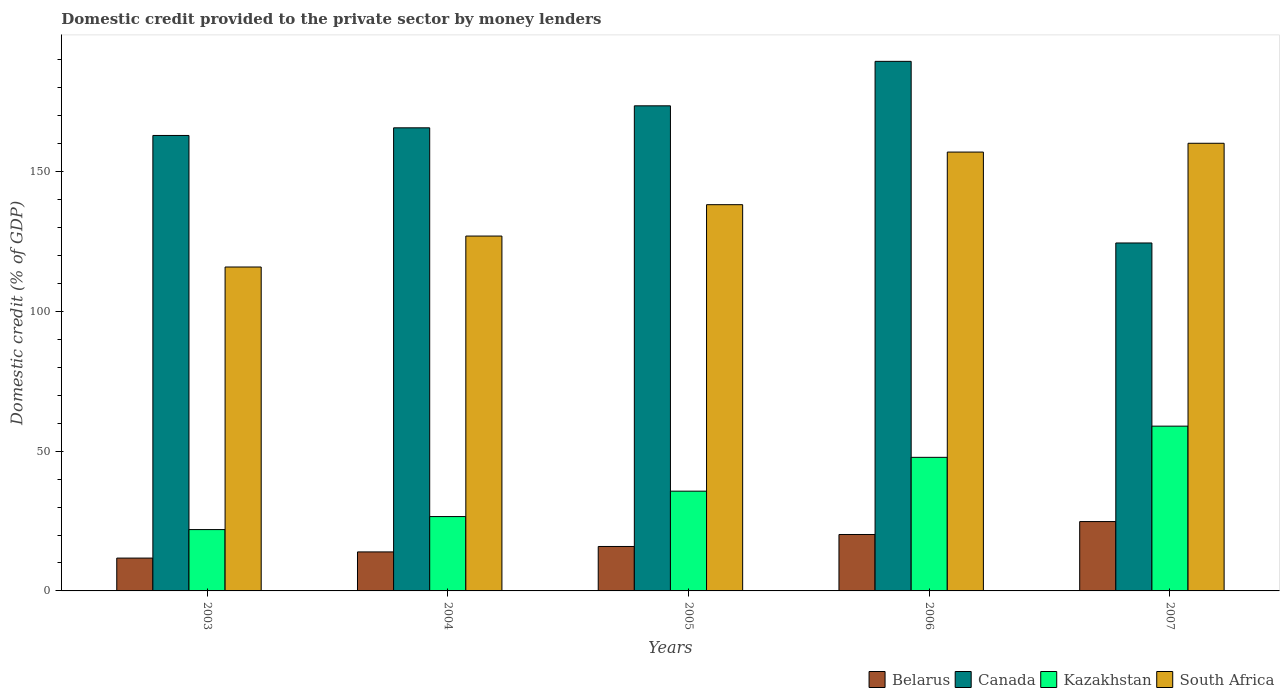Are the number of bars per tick equal to the number of legend labels?
Offer a very short reply. Yes. Are the number of bars on each tick of the X-axis equal?
Ensure brevity in your answer.  Yes. What is the domestic credit provided to the private sector by money lenders in South Africa in 2006?
Your answer should be very brief. 156.98. Across all years, what is the maximum domestic credit provided to the private sector by money lenders in Kazakhstan?
Offer a terse response. 58.94. Across all years, what is the minimum domestic credit provided to the private sector by money lenders in Kazakhstan?
Offer a very short reply. 21.94. What is the total domestic credit provided to the private sector by money lenders in Belarus in the graph?
Make the answer very short. 86.59. What is the difference between the domestic credit provided to the private sector by money lenders in Kazakhstan in 2006 and that in 2007?
Your answer should be compact. -11.16. What is the difference between the domestic credit provided to the private sector by money lenders in Belarus in 2003 and the domestic credit provided to the private sector by money lenders in South Africa in 2004?
Provide a short and direct response. -115.19. What is the average domestic credit provided to the private sector by money lenders in South Africa per year?
Make the answer very short. 139.61. In the year 2003, what is the difference between the domestic credit provided to the private sector by money lenders in South Africa and domestic credit provided to the private sector by money lenders in Canada?
Offer a terse response. -47.05. In how many years, is the domestic credit provided to the private sector by money lenders in Kazakhstan greater than 100 %?
Your answer should be compact. 0. What is the ratio of the domestic credit provided to the private sector by money lenders in Belarus in 2005 to that in 2006?
Make the answer very short. 0.79. Is the difference between the domestic credit provided to the private sector by money lenders in South Africa in 2004 and 2006 greater than the difference between the domestic credit provided to the private sector by money lenders in Canada in 2004 and 2006?
Ensure brevity in your answer.  No. What is the difference between the highest and the second highest domestic credit provided to the private sector by money lenders in Canada?
Your answer should be very brief. 15.91. What is the difference between the highest and the lowest domestic credit provided to the private sector by money lenders in Belarus?
Your answer should be compact. 13.06. In how many years, is the domestic credit provided to the private sector by money lenders in Kazakhstan greater than the average domestic credit provided to the private sector by money lenders in Kazakhstan taken over all years?
Provide a short and direct response. 2. Is the sum of the domestic credit provided to the private sector by money lenders in Belarus in 2004 and 2006 greater than the maximum domestic credit provided to the private sector by money lenders in Canada across all years?
Give a very brief answer. No. What does the 1st bar from the left in 2006 represents?
Offer a terse response. Belarus. What does the 4th bar from the right in 2003 represents?
Offer a very short reply. Belarus. How many bars are there?
Offer a terse response. 20. Are the values on the major ticks of Y-axis written in scientific E-notation?
Offer a terse response. No. Where does the legend appear in the graph?
Your answer should be very brief. Bottom right. How many legend labels are there?
Offer a very short reply. 4. What is the title of the graph?
Provide a short and direct response. Domestic credit provided to the private sector by money lenders. Does "Northern Mariana Islands" appear as one of the legend labels in the graph?
Your response must be concise. No. What is the label or title of the X-axis?
Provide a short and direct response. Years. What is the label or title of the Y-axis?
Your answer should be compact. Domestic credit (% of GDP). What is the Domestic credit (% of GDP) in Belarus in 2003?
Keep it short and to the point. 11.75. What is the Domestic credit (% of GDP) of Canada in 2003?
Offer a terse response. 162.91. What is the Domestic credit (% of GDP) of Kazakhstan in 2003?
Offer a terse response. 21.94. What is the Domestic credit (% of GDP) of South Africa in 2003?
Offer a terse response. 115.86. What is the Domestic credit (% of GDP) in Belarus in 2004?
Your response must be concise. 13.95. What is the Domestic credit (% of GDP) in Canada in 2004?
Offer a terse response. 165.65. What is the Domestic credit (% of GDP) of Kazakhstan in 2004?
Your answer should be compact. 26.59. What is the Domestic credit (% of GDP) in South Africa in 2004?
Offer a terse response. 126.93. What is the Domestic credit (% of GDP) of Belarus in 2005?
Make the answer very short. 15.9. What is the Domestic credit (% of GDP) in Canada in 2005?
Offer a very short reply. 173.52. What is the Domestic credit (% of GDP) in Kazakhstan in 2005?
Your response must be concise. 35.69. What is the Domestic credit (% of GDP) of South Africa in 2005?
Your answer should be very brief. 138.16. What is the Domestic credit (% of GDP) of Belarus in 2006?
Offer a terse response. 20.19. What is the Domestic credit (% of GDP) of Canada in 2006?
Give a very brief answer. 189.43. What is the Domestic credit (% of GDP) in Kazakhstan in 2006?
Your answer should be very brief. 47.78. What is the Domestic credit (% of GDP) of South Africa in 2006?
Offer a terse response. 156.98. What is the Domestic credit (% of GDP) of Belarus in 2007?
Your answer should be compact. 24.8. What is the Domestic credit (% of GDP) of Canada in 2007?
Provide a succinct answer. 124.46. What is the Domestic credit (% of GDP) in Kazakhstan in 2007?
Offer a very short reply. 58.94. What is the Domestic credit (% of GDP) in South Africa in 2007?
Offer a terse response. 160.12. Across all years, what is the maximum Domestic credit (% of GDP) in Belarus?
Provide a succinct answer. 24.8. Across all years, what is the maximum Domestic credit (% of GDP) in Canada?
Offer a terse response. 189.43. Across all years, what is the maximum Domestic credit (% of GDP) of Kazakhstan?
Your response must be concise. 58.94. Across all years, what is the maximum Domestic credit (% of GDP) in South Africa?
Offer a very short reply. 160.12. Across all years, what is the minimum Domestic credit (% of GDP) in Belarus?
Your answer should be compact. 11.75. Across all years, what is the minimum Domestic credit (% of GDP) of Canada?
Your response must be concise. 124.46. Across all years, what is the minimum Domestic credit (% of GDP) of Kazakhstan?
Provide a short and direct response. 21.94. Across all years, what is the minimum Domestic credit (% of GDP) in South Africa?
Offer a very short reply. 115.86. What is the total Domestic credit (% of GDP) in Belarus in the graph?
Offer a terse response. 86.59. What is the total Domestic credit (% of GDP) of Canada in the graph?
Give a very brief answer. 815.97. What is the total Domestic credit (% of GDP) in Kazakhstan in the graph?
Your response must be concise. 190.94. What is the total Domestic credit (% of GDP) in South Africa in the graph?
Provide a succinct answer. 698.05. What is the difference between the Domestic credit (% of GDP) in Belarus in 2003 and that in 2004?
Keep it short and to the point. -2.21. What is the difference between the Domestic credit (% of GDP) in Canada in 2003 and that in 2004?
Offer a terse response. -2.74. What is the difference between the Domestic credit (% of GDP) in Kazakhstan in 2003 and that in 2004?
Offer a terse response. -4.66. What is the difference between the Domestic credit (% of GDP) in South Africa in 2003 and that in 2004?
Offer a terse response. -11.07. What is the difference between the Domestic credit (% of GDP) in Belarus in 2003 and that in 2005?
Give a very brief answer. -4.15. What is the difference between the Domestic credit (% of GDP) in Canada in 2003 and that in 2005?
Ensure brevity in your answer.  -10.6. What is the difference between the Domestic credit (% of GDP) in Kazakhstan in 2003 and that in 2005?
Make the answer very short. -13.75. What is the difference between the Domestic credit (% of GDP) in South Africa in 2003 and that in 2005?
Give a very brief answer. -22.3. What is the difference between the Domestic credit (% of GDP) of Belarus in 2003 and that in 2006?
Provide a succinct answer. -8.44. What is the difference between the Domestic credit (% of GDP) of Canada in 2003 and that in 2006?
Ensure brevity in your answer.  -26.51. What is the difference between the Domestic credit (% of GDP) in Kazakhstan in 2003 and that in 2006?
Offer a terse response. -25.85. What is the difference between the Domestic credit (% of GDP) in South Africa in 2003 and that in 2006?
Your response must be concise. -41.11. What is the difference between the Domestic credit (% of GDP) of Belarus in 2003 and that in 2007?
Offer a very short reply. -13.06. What is the difference between the Domestic credit (% of GDP) of Canada in 2003 and that in 2007?
Give a very brief answer. 38.45. What is the difference between the Domestic credit (% of GDP) of Kazakhstan in 2003 and that in 2007?
Give a very brief answer. -37. What is the difference between the Domestic credit (% of GDP) in South Africa in 2003 and that in 2007?
Your response must be concise. -44.26. What is the difference between the Domestic credit (% of GDP) of Belarus in 2004 and that in 2005?
Keep it short and to the point. -1.95. What is the difference between the Domestic credit (% of GDP) in Canada in 2004 and that in 2005?
Your answer should be very brief. -7.87. What is the difference between the Domestic credit (% of GDP) in Kazakhstan in 2004 and that in 2005?
Your answer should be very brief. -9.09. What is the difference between the Domestic credit (% of GDP) in South Africa in 2004 and that in 2005?
Provide a short and direct response. -11.23. What is the difference between the Domestic credit (% of GDP) of Belarus in 2004 and that in 2006?
Ensure brevity in your answer.  -6.23. What is the difference between the Domestic credit (% of GDP) in Canada in 2004 and that in 2006?
Your answer should be very brief. -23.77. What is the difference between the Domestic credit (% of GDP) of Kazakhstan in 2004 and that in 2006?
Offer a terse response. -21.19. What is the difference between the Domestic credit (% of GDP) of South Africa in 2004 and that in 2006?
Offer a very short reply. -30.04. What is the difference between the Domestic credit (% of GDP) in Belarus in 2004 and that in 2007?
Keep it short and to the point. -10.85. What is the difference between the Domestic credit (% of GDP) of Canada in 2004 and that in 2007?
Provide a succinct answer. 41.19. What is the difference between the Domestic credit (% of GDP) of Kazakhstan in 2004 and that in 2007?
Offer a very short reply. -32.35. What is the difference between the Domestic credit (% of GDP) of South Africa in 2004 and that in 2007?
Ensure brevity in your answer.  -33.19. What is the difference between the Domestic credit (% of GDP) of Belarus in 2005 and that in 2006?
Your answer should be compact. -4.29. What is the difference between the Domestic credit (% of GDP) of Canada in 2005 and that in 2006?
Your answer should be compact. -15.91. What is the difference between the Domestic credit (% of GDP) in Kazakhstan in 2005 and that in 2006?
Your answer should be very brief. -12.1. What is the difference between the Domestic credit (% of GDP) in South Africa in 2005 and that in 2006?
Offer a terse response. -18.82. What is the difference between the Domestic credit (% of GDP) in Belarus in 2005 and that in 2007?
Provide a short and direct response. -8.91. What is the difference between the Domestic credit (% of GDP) of Canada in 2005 and that in 2007?
Keep it short and to the point. 49.06. What is the difference between the Domestic credit (% of GDP) of Kazakhstan in 2005 and that in 2007?
Provide a succinct answer. -23.26. What is the difference between the Domestic credit (% of GDP) of South Africa in 2005 and that in 2007?
Offer a very short reply. -21.97. What is the difference between the Domestic credit (% of GDP) in Belarus in 2006 and that in 2007?
Provide a short and direct response. -4.62. What is the difference between the Domestic credit (% of GDP) in Canada in 2006 and that in 2007?
Your response must be concise. 64.96. What is the difference between the Domestic credit (% of GDP) in Kazakhstan in 2006 and that in 2007?
Your answer should be very brief. -11.16. What is the difference between the Domestic credit (% of GDP) of South Africa in 2006 and that in 2007?
Your answer should be compact. -3.15. What is the difference between the Domestic credit (% of GDP) in Belarus in 2003 and the Domestic credit (% of GDP) in Canada in 2004?
Your response must be concise. -153.9. What is the difference between the Domestic credit (% of GDP) of Belarus in 2003 and the Domestic credit (% of GDP) of Kazakhstan in 2004?
Provide a short and direct response. -14.85. What is the difference between the Domestic credit (% of GDP) of Belarus in 2003 and the Domestic credit (% of GDP) of South Africa in 2004?
Offer a very short reply. -115.19. What is the difference between the Domestic credit (% of GDP) in Canada in 2003 and the Domestic credit (% of GDP) in Kazakhstan in 2004?
Provide a succinct answer. 136.32. What is the difference between the Domestic credit (% of GDP) of Canada in 2003 and the Domestic credit (% of GDP) of South Africa in 2004?
Make the answer very short. 35.98. What is the difference between the Domestic credit (% of GDP) of Kazakhstan in 2003 and the Domestic credit (% of GDP) of South Africa in 2004?
Make the answer very short. -104.99. What is the difference between the Domestic credit (% of GDP) of Belarus in 2003 and the Domestic credit (% of GDP) of Canada in 2005?
Your answer should be compact. -161.77. What is the difference between the Domestic credit (% of GDP) of Belarus in 2003 and the Domestic credit (% of GDP) of Kazakhstan in 2005?
Offer a terse response. -23.94. What is the difference between the Domestic credit (% of GDP) in Belarus in 2003 and the Domestic credit (% of GDP) in South Africa in 2005?
Your response must be concise. -126.41. What is the difference between the Domestic credit (% of GDP) in Canada in 2003 and the Domestic credit (% of GDP) in Kazakhstan in 2005?
Provide a short and direct response. 127.23. What is the difference between the Domestic credit (% of GDP) of Canada in 2003 and the Domestic credit (% of GDP) of South Africa in 2005?
Offer a terse response. 24.76. What is the difference between the Domestic credit (% of GDP) in Kazakhstan in 2003 and the Domestic credit (% of GDP) in South Africa in 2005?
Provide a succinct answer. -116.22. What is the difference between the Domestic credit (% of GDP) of Belarus in 2003 and the Domestic credit (% of GDP) of Canada in 2006?
Offer a very short reply. -177.68. What is the difference between the Domestic credit (% of GDP) of Belarus in 2003 and the Domestic credit (% of GDP) of Kazakhstan in 2006?
Your answer should be very brief. -36.04. What is the difference between the Domestic credit (% of GDP) in Belarus in 2003 and the Domestic credit (% of GDP) in South Africa in 2006?
Offer a terse response. -145.23. What is the difference between the Domestic credit (% of GDP) of Canada in 2003 and the Domestic credit (% of GDP) of Kazakhstan in 2006?
Keep it short and to the point. 115.13. What is the difference between the Domestic credit (% of GDP) in Canada in 2003 and the Domestic credit (% of GDP) in South Africa in 2006?
Give a very brief answer. 5.94. What is the difference between the Domestic credit (% of GDP) of Kazakhstan in 2003 and the Domestic credit (% of GDP) of South Africa in 2006?
Make the answer very short. -135.04. What is the difference between the Domestic credit (% of GDP) of Belarus in 2003 and the Domestic credit (% of GDP) of Canada in 2007?
Make the answer very short. -112.72. What is the difference between the Domestic credit (% of GDP) in Belarus in 2003 and the Domestic credit (% of GDP) in Kazakhstan in 2007?
Ensure brevity in your answer.  -47.2. What is the difference between the Domestic credit (% of GDP) in Belarus in 2003 and the Domestic credit (% of GDP) in South Africa in 2007?
Provide a succinct answer. -148.38. What is the difference between the Domestic credit (% of GDP) of Canada in 2003 and the Domestic credit (% of GDP) of Kazakhstan in 2007?
Keep it short and to the point. 103.97. What is the difference between the Domestic credit (% of GDP) in Canada in 2003 and the Domestic credit (% of GDP) in South Africa in 2007?
Make the answer very short. 2.79. What is the difference between the Domestic credit (% of GDP) of Kazakhstan in 2003 and the Domestic credit (% of GDP) of South Africa in 2007?
Your response must be concise. -138.19. What is the difference between the Domestic credit (% of GDP) of Belarus in 2004 and the Domestic credit (% of GDP) of Canada in 2005?
Provide a short and direct response. -159.57. What is the difference between the Domestic credit (% of GDP) in Belarus in 2004 and the Domestic credit (% of GDP) in Kazakhstan in 2005?
Your answer should be very brief. -21.73. What is the difference between the Domestic credit (% of GDP) of Belarus in 2004 and the Domestic credit (% of GDP) of South Africa in 2005?
Your answer should be very brief. -124.21. What is the difference between the Domestic credit (% of GDP) in Canada in 2004 and the Domestic credit (% of GDP) in Kazakhstan in 2005?
Keep it short and to the point. 129.96. What is the difference between the Domestic credit (% of GDP) of Canada in 2004 and the Domestic credit (% of GDP) of South Africa in 2005?
Make the answer very short. 27.49. What is the difference between the Domestic credit (% of GDP) of Kazakhstan in 2004 and the Domestic credit (% of GDP) of South Africa in 2005?
Your answer should be very brief. -111.57. What is the difference between the Domestic credit (% of GDP) of Belarus in 2004 and the Domestic credit (% of GDP) of Canada in 2006?
Give a very brief answer. -175.47. What is the difference between the Domestic credit (% of GDP) in Belarus in 2004 and the Domestic credit (% of GDP) in Kazakhstan in 2006?
Your answer should be very brief. -33.83. What is the difference between the Domestic credit (% of GDP) of Belarus in 2004 and the Domestic credit (% of GDP) of South Africa in 2006?
Give a very brief answer. -143.02. What is the difference between the Domestic credit (% of GDP) of Canada in 2004 and the Domestic credit (% of GDP) of Kazakhstan in 2006?
Your answer should be compact. 117.87. What is the difference between the Domestic credit (% of GDP) in Canada in 2004 and the Domestic credit (% of GDP) in South Africa in 2006?
Give a very brief answer. 8.67. What is the difference between the Domestic credit (% of GDP) of Kazakhstan in 2004 and the Domestic credit (% of GDP) of South Africa in 2006?
Your response must be concise. -130.38. What is the difference between the Domestic credit (% of GDP) of Belarus in 2004 and the Domestic credit (% of GDP) of Canada in 2007?
Offer a terse response. -110.51. What is the difference between the Domestic credit (% of GDP) in Belarus in 2004 and the Domestic credit (% of GDP) in Kazakhstan in 2007?
Provide a succinct answer. -44.99. What is the difference between the Domestic credit (% of GDP) of Belarus in 2004 and the Domestic credit (% of GDP) of South Africa in 2007?
Your response must be concise. -146.17. What is the difference between the Domestic credit (% of GDP) of Canada in 2004 and the Domestic credit (% of GDP) of Kazakhstan in 2007?
Offer a very short reply. 106.71. What is the difference between the Domestic credit (% of GDP) of Canada in 2004 and the Domestic credit (% of GDP) of South Africa in 2007?
Offer a very short reply. 5.53. What is the difference between the Domestic credit (% of GDP) in Kazakhstan in 2004 and the Domestic credit (% of GDP) in South Africa in 2007?
Your answer should be very brief. -133.53. What is the difference between the Domestic credit (% of GDP) of Belarus in 2005 and the Domestic credit (% of GDP) of Canada in 2006?
Keep it short and to the point. -173.53. What is the difference between the Domestic credit (% of GDP) of Belarus in 2005 and the Domestic credit (% of GDP) of Kazakhstan in 2006?
Make the answer very short. -31.89. What is the difference between the Domestic credit (% of GDP) of Belarus in 2005 and the Domestic credit (% of GDP) of South Africa in 2006?
Ensure brevity in your answer.  -141.08. What is the difference between the Domestic credit (% of GDP) in Canada in 2005 and the Domestic credit (% of GDP) in Kazakhstan in 2006?
Your answer should be compact. 125.74. What is the difference between the Domestic credit (% of GDP) in Canada in 2005 and the Domestic credit (% of GDP) in South Africa in 2006?
Provide a short and direct response. 16.54. What is the difference between the Domestic credit (% of GDP) of Kazakhstan in 2005 and the Domestic credit (% of GDP) of South Africa in 2006?
Make the answer very short. -121.29. What is the difference between the Domestic credit (% of GDP) in Belarus in 2005 and the Domestic credit (% of GDP) in Canada in 2007?
Provide a short and direct response. -108.56. What is the difference between the Domestic credit (% of GDP) in Belarus in 2005 and the Domestic credit (% of GDP) in Kazakhstan in 2007?
Your response must be concise. -43.04. What is the difference between the Domestic credit (% of GDP) of Belarus in 2005 and the Domestic credit (% of GDP) of South Africa in 2007?
Offer a very short reply. -144.23. What is the difference between the Domestic credit (% of GDP) in Canada in 2005 and the Domestic credit (% of GDP) in Kazakhstan in 2007?
Keep it short and to the point. 114.58. What is the difference between the Domestic credit (% of GDP) of Canada in 2005 and the Domestic credit (% of GDP) of South Africa in 2007?
Ensure brevity in your answer.  13.39. What is the difference between the Domestic credit (% of GDP) in Kazakhstan in 2005 and the Domestic credit (% of GDP) in South Africa in 2007?
Ensure brevity in your answer.  -124.44. What is the difference between the Domestic credit (% of GDP) of Belarus in 2006 and the Domestic credit (% of GDP) of Canada in 2007?
Your answer should be very brief. -104.28. What is the difference between the Domestic credit (% of GDP) in Belarus in 2006 and the Domestic credit (% of GDP) in Kazakhstan in 2007?
Give a very brief answer. -38.76. What is the difference between the Domestic credit (% of GDP) of Belarus in 2006 and the Domestic credit (% of GDP) of South Africa in 2007?
Provide a short and direct response. -139.94. What is the difference between the Domestic credit (% of GDP) of Canada in 2006 and the Domestic credit (% of GDP) of Kazakhstan in 2007?
Give a very brief answer. 130.48. What is the difference between the Domestic credit (% of GDP) of Canada in 2006 and the Domestic credit (% of GDP) of South Africa in 2007?
Make the answer very short. 29.3. What is the difference between the Domestic credit (% of GDP) in Kazakhstan in 2006 and the Domestic credit (% of GDP) in South Africa in 2007?
Keep it short and to the point. -112.34. What is the average Domestic credit (% of GDP) of Belarus per year?
Offer a very short reply. 17.32. What is the average Domestic credit (% of GDP) of Canada per year?
Provide a succinct answer. 163.19. What is the average Domestic credit (% of GDP) of Kazakhstan per year?
Your response must be concise. 38.19. What is the average Domestic credit (% of GDP) in South Africa per year?
Your response must be concise. 139.61. In the year 2003, what is the difference between the Domestic credit (% of GDP) in Belarus and Domestic credit (% of GDP) in Canada?
Your answer should be very brief. -151.17. In the year 2003, what is the difference between the Domestic credit (% of GDP) in Belarus and Domestic credit (% of GDP) in Kazakhstan?
Offer a very short reply. -10.19. In the year 2003, what is the difference between the Domestic credit (% of GDP) in Belarus and Domestic credit (% of GDP) in South Africa?
Your answer should be very brief. -104.12. In the year 2003, what is the difference between the Domestic credit (% of GDP) in Canada and Domestic credit (% of GDP) in Kazakhstan?
Keep it short and to the point. 140.98. In the year 2003, what is the difference between the Domestic credit (% of GDP) in Canada and Domestic credit (% of GDP) in South Africa?
Offer a terse response. 47.05. In the year 2003, what is the difference between the Domestic credit (% of GDP) in Kazakhstan and Domestic credit (% of GDP) in South Africa?
Offer a very short reply. -93.92. In the year 2004, what is the difference between the Domestic credit (% of GDP) in Belarus and Domestic credit (% of GDP) in Canada?
Your response must be concise. -151.7. In the year 2004, what is the difference between the Domestic credit (% of GDP) in Belarus and Domestic credit (% of GDP) in Kazakhstan?
Offer a terse response. -12.64. In the year 2004, what is the difference between the Domestic credit (% of GDP) in Belarus and Domestic credit (% of GDP) in South Africa?
Ensure brevity in your answer.  -112.98. In the year 2004, what is the difference between the Domestic credit (% of GDP) of Canada and Domestic credit (% of GDP) of Kazakhstan?
Give a very brief answer. 139.06. In the year 2004, what is the difference between the Domestic credit (% of GDP) of Canada and Domestic credit (% of GDP) of South Africa?
Keep it short and to the point. 38.72. In the year 2004, what is the difference between the Domestic credit (% of GDP) of Kazakhstan and Domestic credit (% of GDP) of South Africa?
Give a very brief answer. -100.34. In the year 2005, what is the difference between the Domestic credit (% of GDP) of Belarus and Domestic credit (% of GDP) of Canada?
Your response must be concise. -157.62. In the year 2005, what is the difference between the Domestic credit (% of GDP) in Belarus and Domestic credit (% of GDP) in Kazakhstan?
Your answer should be compact. -19.79. In the year 2005, what is the difference between the Domestic credit (% of GDP) of Belarus and Domestic credit (% of GDP) of South Africa?
Your response must be concise. -122.26. In the year 2005, what is the difference between the Domestic credit (% of GDP) of Canada and Domestic credit (% of GDP) of Kazakhstan?
Ensure brevity in your answer.  137.83. In the year 2005, what is the difference between the Domestic credit (% of GDP) in Canada and Domestic credit (% of GDP) in South Africa?
Keep it short and to the point. 35.36. In the year 2005, what is the difference between the Domestic credit (% of GDP) in Kazakhstan and Domestic credit (% of GDP) in South Africa?
Offer a terse response. -102.47. In the year 2006, what is the difference between the Domestic credit (% of GDP) in Belarus and Domestic credit (% of GDP) in Canada?
Your answer should be compact. -169.24. In the year 2006, what is the difference between the Domestic credit (% of GDP) in Belarus and Domestic credit (% of GDP) in Kazakhstan?
Provide a succinct answer. -27.6. In the year 2006, what is the difference between the Domestic credit (% of GDP) of Belarus and Domestic credit (% of GDP) of South Africa?
Offer a very short reply. -136.79. In the year 2006, what is the difference between the Domestic credit (% of GDP) in Canada and Domestic credit (% of GDP) in Kazakhstan?
Ensure brevity in your answer.  141.64. In the year 2006, what is the difference between the Domestic credit (% of GDP) in Canada and Domestic credit (% of GDP) in South Africa?
Your answer should be compact. 32.45. In the year 2006, what is the difference between the Domestic credit (% of GDP) of Kazakhstan and Domestic credit (% of GDP) of South Africa?
Make the answer very short. -109.19. In the year 2007, what is the difference between the Domestic credit (% of GDP) in Belarus and Domestic credit (% of GDP) in Canada?
Offer a very short reply. -99.66. In the year 2007, what is the difference between the Domestic credit (% of GDP) of Belarus and Domestic credit (% of GDP) of Kazakhstan?
Your response must be concise. -34.14. In the year 2007, what is the difference between the Domestic credit (% of GDP) of Belarus and Domestic credit (% of GDP) of South Africa?
Ensure brevity in your answer.  -135.32. In the year 2007, what is the difference between the Domestic credit (% of GDP) of Canada and Domestic credit (% of GDP) of Kazakhstan?
Make the answer very short. 65.52. In the year 2007, what is the difference between the Domestic credit (% of GDP) of Canada and Domestic credit (% of GDP) of South Africa?
Give a very brief answer. -35.66. In the year 2007, what is the difference between the Domestic credit (% of GDP) of Kazakhstan and Domestic credit (% of GDP) of South Africa?
Offer a terse response. -101.18. What is the ratio of the Domestic credit (% of GDP) in Belarus in 2003 to that in 2004?
Your answer should be compact. 0.84. What is the ratio of the Domestic credit (% of GDP) in Canada in 2003 to that in 2004?
Your answer should be very brief. 0.98. What is the ratio of the Domestic credit (% of GDP) in Kazakhstan in 2003 to that in 2004?
Ensure brevity in your answer.  0.82. What is the ratio of the Domestic credit (% of GDP) of South Africa in 2003 to that in 2004?
Your answer should be compact. 0.91. What is the ratio of the Domestic credit (% of GDP) in Belarus in 2003 to that in 2005?
Provide a short and direct response. 0.74. What is the ratio of the Domestic credit (% of GDP) of Canada in 2003 to that in 2005?
Make the answer very short. 0.94. What is the ratio of the Domestic credit (% of GDP) of Kazakhstan in 2003 to that in 2005?
Your answer should be compact. 0.61. What is the ratio of the Domestic credit (% of GDP) of South Africa in 2003 to that in 2005?
Make the answer very short. 0.84. What is the ratio of the Domestic credit (% of GDP) in Belarus in 2003 to that in 2006?
Your response must be concise. 0.58. What is the ratio of the Domestic credit (% of GDP) of Canada in 2003 to that in 2006?
Offer a very short reply. 0.86. What is the ratio of the Domestic credit (% of GDP) of Kazakhstan in 2003 to that in 2006?
Your response must be concise. 0.46. What is the ratio of the Domestic credit (% of GDP) in South Africa in 2003 to that in 2006?
Your answer should be very brief. 0.74. What is the ratio of the Domestic credit (% of GDP) of Belarus in 2003 to that in 2007?
Make the answer very short. 0.47. What is the ratio of the Domestic credit (% of GDP) in Canada in 2003 to that in 2007?
Offer a very short reply. 1.31. What is the ratio of the Domestic credit (% of GDP) in Kazakhstan in 2003 to that in 2007?
Provide a short and direct response. 0.37. What is the ratio of the Domestic credit (% of GDP) of South Africa in 2003 to that in 2007?
Ensure brevity in your answer.  0.72. What is the ratio of the Domestic credit (% of GDP) in Belarus in 2004 to that in 2005?
Your answer should be compact. 0.88. What is the ratio of the Domestic credit (% of GDP) in Canada in 2004 to that in 2005?
Provide a succinct answer. 0.95. What is the ratio of the Domestic credit (% of GDP) of Kazakhstan in 2004 to that in 2005?
Ensure brevity in your answer.  0.75. What is the ratio of the Domestic credit (% of GDP) in South Africa in 2004 to that in 2005?
Ensure brevity in your answer.  0.92. What is the ratio of the Domestic credit (% of GDP) in Belarus in 2004 to that in 2006?
Keep it short and to the point. 0.69. What is the ratio of the Domestic credit (% of GDP) of Canada in 2004 to that in 2006?
Provide a succinct answer. 0.87. What is the ratio of the Domestic credit (% of GDP) in Kazakhstan in 2004 to that in 2006?
Ensure brevity in your answer.  0.56. What is the ratio of the Domestic credit (% of GDP) in South Africa in 2004 to that in 2006?
Give a very brief answer. 0.81. What is the ratio of the Domestic credit (% of GDP) in Belarus in 2004 to that in 2007?
Provide a short and direct response. 0.56. What is the ratio of the Domestic credit (% of GDP) of Canada in 2004 to that in 2007?
Your answer should be very brief. 1.33. What is the ratio of the Domestic credit (% of GDP) of Kazakhstan in 2004 to that in 2007?
Your response must be concise. 0.45. What is the ratio of the Domestic credit (% of GDP) in South Africa in 2004 to that in 2007?
Your response must be concise. 0.79. What is the ratio of the Domestic credit (% of GDP) in Belarus in 2005 to that in 2006?
Make the answer very short. 0.79. What is the ratio of the Domestic credit (% of GDP) in Canada in 2005 to that in 2006?
Your answer should be compact. 0.92. What is the ratio of the Domestic credit (% of GDP) of Kazakhstan in 2005 to that in 2006?
Offer a terse response. 0.75. What is the ratio of the Domestic credit (% of GDP) of South Africa in 2005 to that in 2006?
Your answer should be compact. 0.88. What is the ratio of the Domestic credit (% of GDP) in Belarus in 2005 to that in 2007?
Make the answer very short. 0.64. What is the ratio of the Domestic credit (% of GDP) of Canada in 2005 to that in 2007?
Your answer should be very brief. 1.39. What is the ratio of the Domestic credit (% of GDP) of Kazakhstan in 2005 to that in 2007?
Your answer should be compact. 0.61. What is the ratio of the Domestic credit (% of GDP) in South Africa in 2005 to that in 2007?
Your answer should be very brief. 0.86. What is the ratio of the Domestic credit (% of GDP) in Belarus in 2006 to that in 2007?
Your answer should be compact. 0.81. What is the ratio of the Domestic credit (% of GDP) of Canada in 2006 to that in 2007?
Ensure brevity in your answer.  1.52. What is the ratio of the Domestic credit (% of GDP) in Kazakhstan in 2006 to that in 2007?
Your answer should be compact. 0.81. What is the ratio of the Domestic credit (% of GDP) in South Africa in 2006 to that in 2007?
Ensure brevity in your answer.  0.98. What is the difference between the highest and the second highest Domestic credit (% of GDP) in Belarus?
Ensure brevity in your answer.  4.62. What is the difference between the highest and the second highest Domestic credit (% of GDP) of Canada?
Provide a succinct answer. 15.91. What is the difference between the highest and the second highest Domestic credit (% of GDP) in Kazakhstan?
Offer a very short reply. 11.16. What is the difference between the highest and the second highest Domestic credit (% of GDP) in South Africa?
Provide a short and direct response. 3.15. What is the difference between the highest and the lowest Domestic credit (% of GDP) of Belarus?
Give a very brief answer. 13.06. What is the difference between the highest and the lowest Domestic credit (% of GDP) in Canada?
Give a very brief answer. 64.96. What is the difference between the highest and the lowest Domestic credit (% of GDP) of Kazakhstan?
Your response must be concise. 37. What is the difference between the highest and the lowest Domestic credit (% of GDP) of South Africa?
Ensure brevity in your answer.  44.26. 